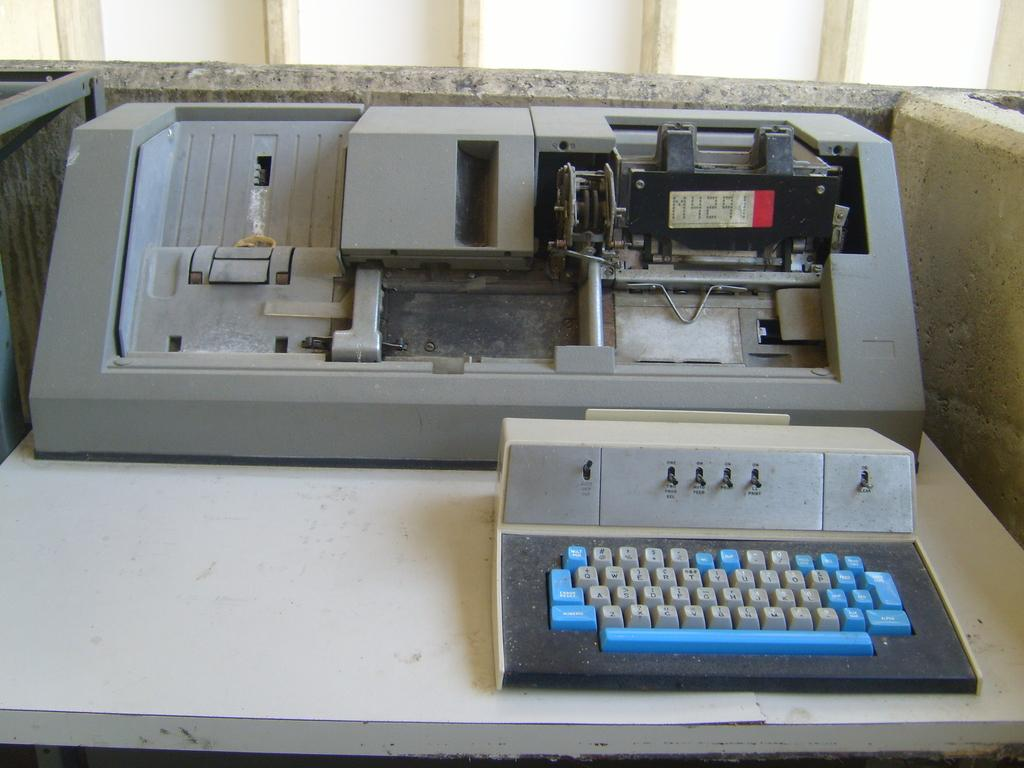<image>
Relay a brief, clear account of the picture shown. An old piece of machinery with the coding M4291 on it. 